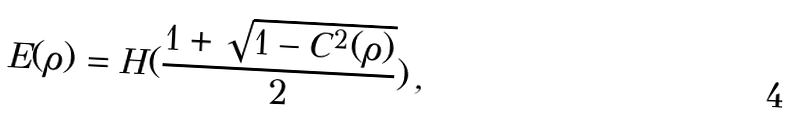<formula> <loc_0><loc_0><loc_500><loc_500>E ( \rho ) = H ( \frac { 1 + \sqrt { 1 - C ^ { 2 } ( \rho ) } } { 2 } ) \, ,</formula> 